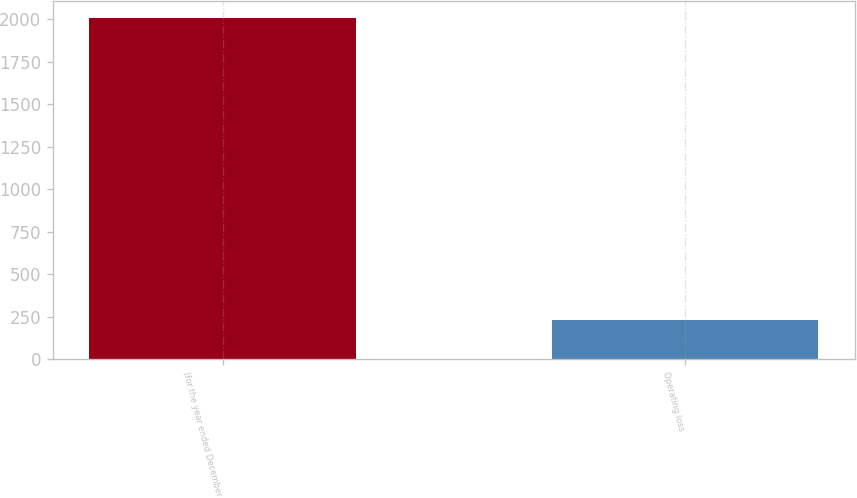Convert chart. <chart><loc_0><loc_0><loc_500><loc_500><bar_chart><fcel>(for the year ended December<fcel>Operating loss<nl><fcel>2009<fcel>233<nl></chart> 